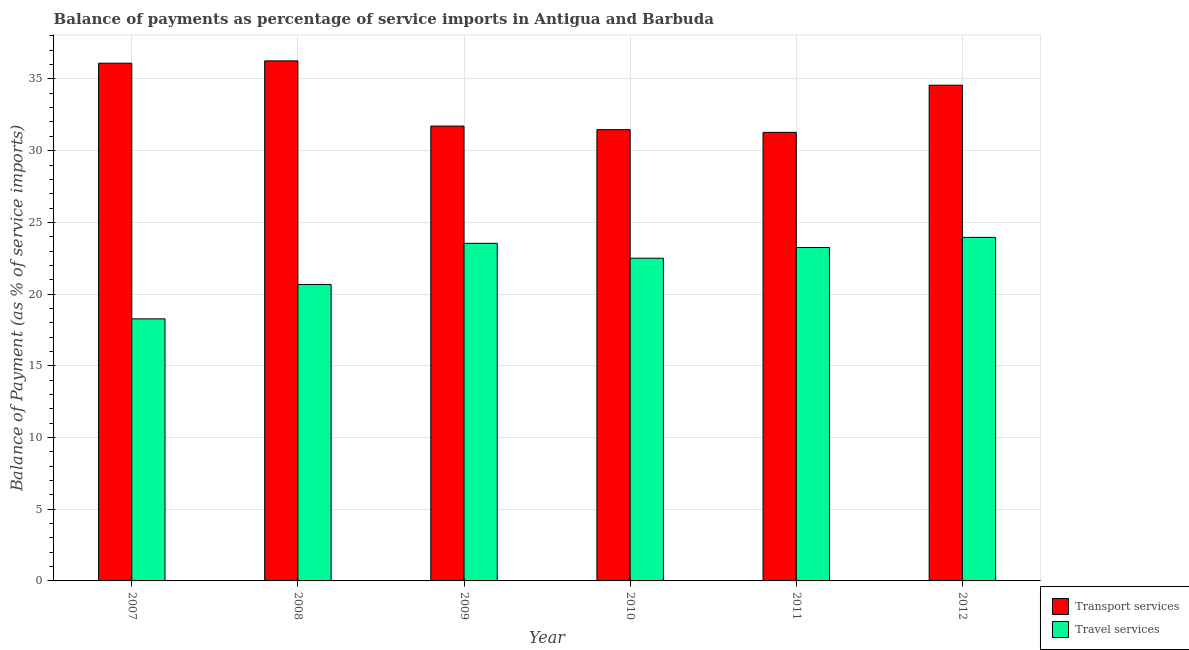How many bars are there on the 2nd tick from the left?
Offer a terse response. 2. In how many cases, is the number of bars for a given year not equal to the number of legend labels?
Give a very brief answer. 0. What is the balance of payments of transport services in 2007?
Your response must be concise. 36.1. Across all years, what is the maximum balance of payments of transport services?
Provide a short and direct response. 36.26. Across all years, what is the minimum balance of payments of travel services?
Your response must be concise. 18.27. In which year was the balance of payments of transport services minimum?
Your answer should be compact. 2011. What is the total balance of payments of travel services in the graph?
Provide a succinct answer. 132.19. What is the difference between the balance of payments of transport services in 2008 and that in 2011?
Your response must be concise. 4.98. What is the difference between the balance of payments of travel services in 2012 and the balance of payments of transport services in 2010?
Your answer should be very brief. 1.45. What is the average balance of payments of travel services per year?
Provide a succinct answer. 22.03. In the year 2009, what is the difference between the balance of payments of travel services and balance of payments of transport services?
Your answer should be very brief. 0. In how many years, is the balance of payments of travel services greater than 9 %?
Provide a succinct answer. 6. What is the ratio of the balance of payments of travel services in 2011 to that in 2012?
Provide a short and direct response. 0.97. Is the difference between the balance of payments of travel services in 2010 and 2012 greater than the difference between the balance of payments of transport services in 2010 and 2012?
Your answer should be compact. No. What is the difference between the highest and the second highest balance of payments of transport services?
Provide a short and direct response. 0.16. What is the difference between the highest and the lowest balance of payments of travel services?
Keep it short and to the point. 5.68. In how many years, is the balance of payments of travel services greater than the average balance of payments of travel services taken over all years?
Your answer should be very brief. 4. Is the sum of the balance of payments of transport services in 2009 and 2010 greater than the maximum balance of payments of travel services across all years?
Offer a very short reply. Yes. What does the 1st bar from the left in 2008 represents?
Give a very brief answer. Transport services. What does the 1st bar from the right in 2008 represents?
Provide a succinct answer. Travel services. Are all the bars in the graph horizontal?
Your answer should be very brief. No. Are the values on the major ticks of Y-axis written in scientific E-notation?
Your answer should be very brief. No. Does the graph contain any zero values?
Your answer should be very brief. No. How many legend labels are there?
Provide a succinct answer. 2. How are the legend labels stacked?
Provide a succinct answer. Vertical. What is the title of the graph?
Your response must be concise. Balance of payments as percentage of service imports in Antigua and Barbuda. What is the label or title of the X-axis?
Offer a very short reply. Year. What is the label or title of the Y-axis?
Make the answer very short. Balance of Payment (as % of service imports). What is the Balance of Payment (as % of service imports) of Transport services in 2007?
Ensure brevity in your answer.  36.1. What is the Balance of Payment (as % of service imports) of Travel services in 2007?
Offer a terse response. 18.27. What is the Balance of Payment (as % of service imports) of Transport services in 2008?
Make the answer very short. 36.26. What is the Balance of Payment (as % of service imports) in Travel services in 2008?
Ensure brevity in your answer.  20.67. What is the Balance of Payment (as % of service imports) in Transport services in 2009?
Keep it short and to the point. 31.72. What is the Balance of Payment (as % of service imports) in Travel services in 2009?
Provide a short and direct response. 23.54. What is the Balance of Payment (as % of service imports) in Transport services in 2010?
Your answer should be compact. 31.47. What is the Balance of Payment (as % of service imports) in Travel services in 2010?
Give a very brief answer. 22.5. What is the Balance of Payment (as % of service imports) in Transport services in 2011?
Your response must be concise. 31.28. What is the Balance of Payment (as % of service imports) in Travel services in 2011?
Offer a very short reply. 23.25. What is the Balance of Payment (as % of service imports) of Transport services in 2012?
Give a very brief answer. 34.57. What is the Balance of Payment (as % of service imports) in Travel services in 2012?
Your answer should be compact. 23.95. Across all years, what is the maximum Balance of Payment (as % of service imports) in Transport services?
Your answer should be compact. 36.26. Across all years, what is the maximum Balance of Payment (as % of service imports) of Travel services?
Provide a succinct answer. 23.95. Across all years, what is the minimum Balance of Payment (as % of service imports) of Transport services?
Offer a terse response. 31.28. Across all years, what is the minimum Balance of Payment (as % of service imports) in Travel services?
Your answer should be compact. 18.27. What is the total Balance of Payment (as % of service imports) of Transport services in the graph?
Make the answer very short. 201.39. What is the total Balance of Payment (as % of service imports) of Travel services in the graph?
Your answer should be very brief. 132.19. What is the difference between the Balance of Payment (as % of service imports) of Transport services in 2007 and that in 2008?
Provide a succinct answer. -0.16. What is the difference between the Balance of Payment (as % of service imports) in Travel services in 2007 and that in 2008?
Ensure brevity in your answer.  -2.4. What is the difference between the Balance of Payment (as % of service imports) in Transport services in 2007 and that in 2009?
Make the answer very short. 4.38. What is the difference between the Balance of Payment (as % of service imports) in Travel services in 2007 and that in 2009?
Make the answer very short. -5.26. What is the difference between the Balance of Payment (as % of service imports) in Transport services in 2007 and that in 2010?
Offer a terse response. 4.63. What is the difference between the Balance of Payment (as % of service imports) in Travel services in 2007 and that in 2010?
Make the answer very short. -4.23. What is the difference between the Balance of Payment (as % of service imports) in Transport services in 2007 and that in 2011?
Ensure brevity in your answer.  4.82. What is the difference between the Balance of Payment (as % of service imports) in Travel services in 2007 and that in 2011?
Make the answer very short. -4.97. What is the difference between the Balance of Payment (as % of service imports) of Transport services in 2007 and that in 2012?
Offer a terse response. 1.53. What is the difference between the Balance of Payment (as % of service imports) in Travel services in 2007 and that in 2012?
Ensure brevity in your answer.  -5.68. What is the difference between the Balance of Payment (as % of service imports) of Transport services in 2008 and that in 2009?
Your response must be concise. 4.55. What is the difference between the Balance of Payment (as % of service imports) in Travel services in 2008 and that in 2009?
Provide a succinct answer. -2.87. What is the difference between the Balance of Payment (as % of service imports) in Transport services in 2008 and that in 2010?
Provide a succinct answer. 4.8. What is the difference between the Balance of Payment (as % of service imports) of Travel services in 2008 and that in 2010?
Make the answer very short. -1.83. What is the difference between the Balance of Payment (as % of service imports) of Transport services in 2008 and that in 2011?
Offer a terse response. 4.98. What is the difference between the Balance of Payment (as % of service imports) in Travel services in 2008 and that in 2011?
Give a very brief answer. -2.58. What is the difference between the Balance of Payment (as % of service imports) of Transport services in 2008 and that in 2012?
Provide a succinct answer. 1.7. What is the difference between the Balance of Payment (as % of service imports) in Travel services in 2008 and that in 2012?
Give a very brief answer. -3.28. What is the difference between the Balance of Payment (as % of service imports) of Travel services in 2009 and that in 2010?
Offer a very short reply. 1.04. What is the difference between the Balance of Payment (as % of service imports) of Transport services in 2009 and that in 2011?
Provide a succinct answer. 0.44. What is the difference between the Balance of Payment (as % of service imports) in Travel services in 2009 and that in 2011?
Ensure brevity in your answer.  0.29. What is the difference between the Balance of Payment (as % of service imports) of Transport services in 2009 and that in 2012?
Offer a very short reply. -2.85. What is the difference between the Balance of Payment (as % of service imports) of Travel services in 2009 and that in 2012?
Make the answer very short. -0.42. What is the difference between the Balance of Payment (as % of service imports) of Transport services in 2010 and that in 2011?
Make the answer very short. 0.19. What is the difference between the Balance of Payment (as % of service imports) of Travel services in 2010 and that in 2011?
Offer a terse response. -0.75. What is the difference between the Balance of Payment (as % of service imports) in Transport services in 2010 and that in 2012?
Offer a very short reply. -3.1. What is the difference between the Balance of Payment (as % of service imports) of Travel services in 2010 and that in 2012?
Offer a terse response. -1.45. What is the difference between the Balance of Payment (as % of service imports) in Transport services in 2011 and that in 2012?
Your answer should be very brief. -3.29. What is the difference between the Balance of Payment (as % of service imports) in Travel services in 2011 and that in 2012?
Your response must be concise. -0.71. What is the difference between the Balance of Payment (as % of service imports) of Transport services in 2007 and the Balance of Payment (as % of service imports) of Travel services in 2008?
Your response must be concise. 15.43. What is the difference between the Balance of Payment (as % of service imports) of Transport services in 2007 and the Balance of Payment (as % of service imports) of Travel services in 2009?
Offer a very short reply. 12.56. What is the difference between the Balance of Payment (as % of service imports) in Transport services in 2007 and the Balance of Payment (as % of service imports) in Travel services in 2010?
Provide a succinct answer. 13.6. What is the difference between the Balance of Payment (as % of service imports) in Transport services in 2007 and the Balance of Payment (as % of service imports) in Travel services in 2011?
Your answer should be very brief. 12.85. What is the difference between the Balance of Payment (as % of service imports) of Transport services in 2007 and the Balance of Payment (as % of service imports) of Travel services in 2012?
Offer a terse response. 12.14. What is the difference between the Balance of Payment (as % of service imports) in Transport services in 2008 and the Balance of Payment (as % of service imports) in Travel services in 2009?
Provide a short and direct response. 12.72. What is the difference between the Balance of Payment (as % of service imports) in Transport services in 2008 and the Balance of Payment (as % of service imports) in Travel services in 2010?
Provide a short and direct response. 13.76. What is the difference between the Balance of Payment (as % of service imports) in Transport services in 2008 and the Balance of Payment (as % of service imports) in Travel services in 2011?
Provide a succinct answer. 13.01. What is the difference between the Balance of Payment (as % of service imports) of Transport services in 2008 and the Balance of Payment (as % of service imports) of Travel services in 2012?
Your response must be concise. 12.31. What is the difference between the Balance of Payment (as % of service imports) in Transport services in 2009 and the Balance of Payment (as % of service imports) in Travel services in 2010?
Your answer should be very brief. 9.21. What is the difference between the Balance of Payment (as % of service imports) of Transport services in 2009 and the Balance of Payment (as % of service imports) of Travel services in 2011?
Your response must be concise. 8.47. What is the difference between the Balance of Payment (as % of service imports) of Transport services in 2009 and the Balance of Payment (as % of service imports) of Travel services in 2012?
Keep it short and to the point. 7.76. What is the difference between the Balance of Payment (as % of service imports) in Transport services in 2010 and the Balance of Payment (as % of service imports) in Travel services in 2011?
Ensure brevity in your answer.  8.22. What is the difference between the Balance of Payment (as % of service imports) of Transport services in 2010 and the Balance of Payment (as % of service imports) of Travel services in 2012?
Your answer should be compact. 7.51. What is the difference between the Balance of Payment (as % of service imports) in Transport services in 2011 and the Balance of Payment (as % of service imports) in Travel services in 2012?
Offer a very short reply. 7.32. What is the average Balance of Payment (as % of service imports) in Transport services per year?
Offer a very short reply. 33.56. What is the average Balance of Payment (as % of service imports) in Travel services per year?
Your response must be concise. 22.03. In the year 2007, what is the difference between the Balance of Payment (as % of service imports) of Transport services and Balance of Payment (as % of service imports) of Travel services?
Ensure brevity in your answer.  17.82. In the year 2008, what is the difference between the Balance of Payment (as % of service imports) of Transport services and Balance of Payment (as % of service imports) of Travel services?
Offer a terse response. 15.59. In the year 2009, what is the difference between the Balance of Payment (as % of service imports) of Transport services and Balance of Payment (as % of service imports) of Travel services?
Give a very brief answer. 8.18. In the year 2010, what is the difference between the Balance of Payment (as % of service imports) of Transport services and Balance of Payment (as % of service imports) of Travel services?
Offer a terse response. 8.96. In the year 2011, what is the difference between the Balance of Payment (as % of service imports) of Transport services and Balance of Payment (as % of service imports) of Travel services?
Ensure brevity in your answer.  8.03. In the year 2012, what is the difference between the Balance of Payment (as % of service imports) of Transport services and Balance of Payment (as % of service imports) of Travel services?
Offer a terse response. 10.61. What is the ratio of the Balance of Payment (as % of service imports) of Transport services in 2007 to that in 2008?
Offer a terse response. 1. What is the ratio of the Balance of Payment (as % of service imports) of Travel services in 2007 to that in 2008?
Your answer should be very brief. 0.88. What is the ratio of the Balance of Payment (as % of service imports) in Transport services in 2007 to that in 2009?
Your answer should be compact. 1.14. What is the ratio of the Balance of Payment (as % of service imports) in Travel services in 2007 to that in 2009?
Offer a very short reply. 0.78. What is the ratio of the Balance of Payment (as % of service imports) in Transport services in 2007 to that in 2010?
Offer a terse response. 1.15. What is the ratio of the Balance of Payment (as % of service imports) of Travel services in 2007 to that in 2010?
Ensure brevity in your answer.  0.81. What is the ratio of the Balance of Payment (as % of service imports) of Transport services in 2007 to that in 2011?
Make the answer very short. 1.15. What is the ratio of the Balance of Payment (as % of service imports) in Travel services in 2007 to that in 2011?
Provide a succinct answer. 0.79. What is the ratio of the Balance of Payment (as % of service imports) in Transport services in 2007 to that in 2012?
Make the answer very short. 1.04. What is the ratio of the Balance of Payment (as % of service imports) in Travel services in 2007 to that in 2012?
Provide a short and direct response. 0.76. What is the ratio of the Balance of Payment (as % of service imports) in Transport services in 2008 to that in 2009?
Offer a terse response. 1.14. What is the ratio of the Balance of Payment (as % of service imports) in Travel services in 2008 to that in 2009?
Offer a terse response. 0.88. What is the ratio of the Balance of Payment (as % of service imports) in Transport services in 2008 to that in 2010?
Offer a very short reply. 1.15. What is the ratio of the Balance of Payment (as % of service imports) of Travel services in 2008 to that in 2010?
Offer a terse response. 0.92. What is the ratio of the Balance of Payment (as % of service imports) of Transport services in 2008 to that in 2011?
Your response must be concise. 1.16. What is the ratio of the Balance of Payment (as % of service imports) in Travel services in 2008 to that in 2011?
Your response must be concise. 0.89. What is the ratio of the Balance of Payment (as % of service imports) in Transport services in 2008 to that in 2012?
Your response must be concise. 1.05. What is the ratio of the Balance of Payment (as % of service imports) of Travel services in 2008 to that in 2012?
Offer a terse response. 0.86. What is the ratio of the Balance of Payment (as % of service imports) in Transport services in 2009 to that in 2010?
Your response must be concise. 1.01. What is the ratio of the Balance of Payment (as % of service imports) of Travel services in 2009 to that in 2010?
Keep it short and to the point. 1.05. What is the ratio of the Balance of Payment (as % of service imports) of Transport services in 2009 to that in 2011?
Provide a short and direct response. 1.01. What is the ratio of the Balance of Payment (as % of service imports) in Travel services in 2009 to that in 2011?
Ensure brevity in your answer.  1.01. What is the ratio of the Balance of Payment (as % of service imports) of Transport services in 2009 to that in 2012?
Your response must be concise. 0.92. What is the ratio of the Balance of Payment (as % of service imports) in Travel services in 2009 to that in 2012?
Ensure brevity in your answer.  0.98. What is the ratio of the Balance of Payment (as % of service imports) of Travel services in 2010 to that in 2011?
Provide a short and direct response. 0.97. What is the ratio of the Balance of Payment (as % of service imports) in Transport services in 2010 to that in 2012?
Give a very brief answer. 0.91. What is the ratio of the Balance of Payment (as % of service imports) in Travel services in 2010 to that in 2012?
Your answer should be very brief. 0.94. What is the ratio of the Balance of Payment (as % of service imports) in Transport services in 2011 to that in 2012?
Keep it short and to the point. 0.9. What is the ratio of the Balance of Payment (as % of service imports) in Travel services in 2011 to that in 2012?
Your answer should be very brief. 0.97. What is the difference between the highest and the second highest Balance of Payment (as % of service imports) in Transport services?
Keep it short and to the point. 0.16. What is the difference between the highest and the second highest Balance of Payment (as % of service imports) in Travel services?
Your answer should be compact. 0.42. What is the difference between the highest and the lowest Balance of Payment (as % of service imports) of Transport services?
Your answer should be very brief. 4.98. What is the difference between the highest and the lowest Balance of Payment (as % of service imports) in Travel services?
Give a very brief answer. 5.68. 